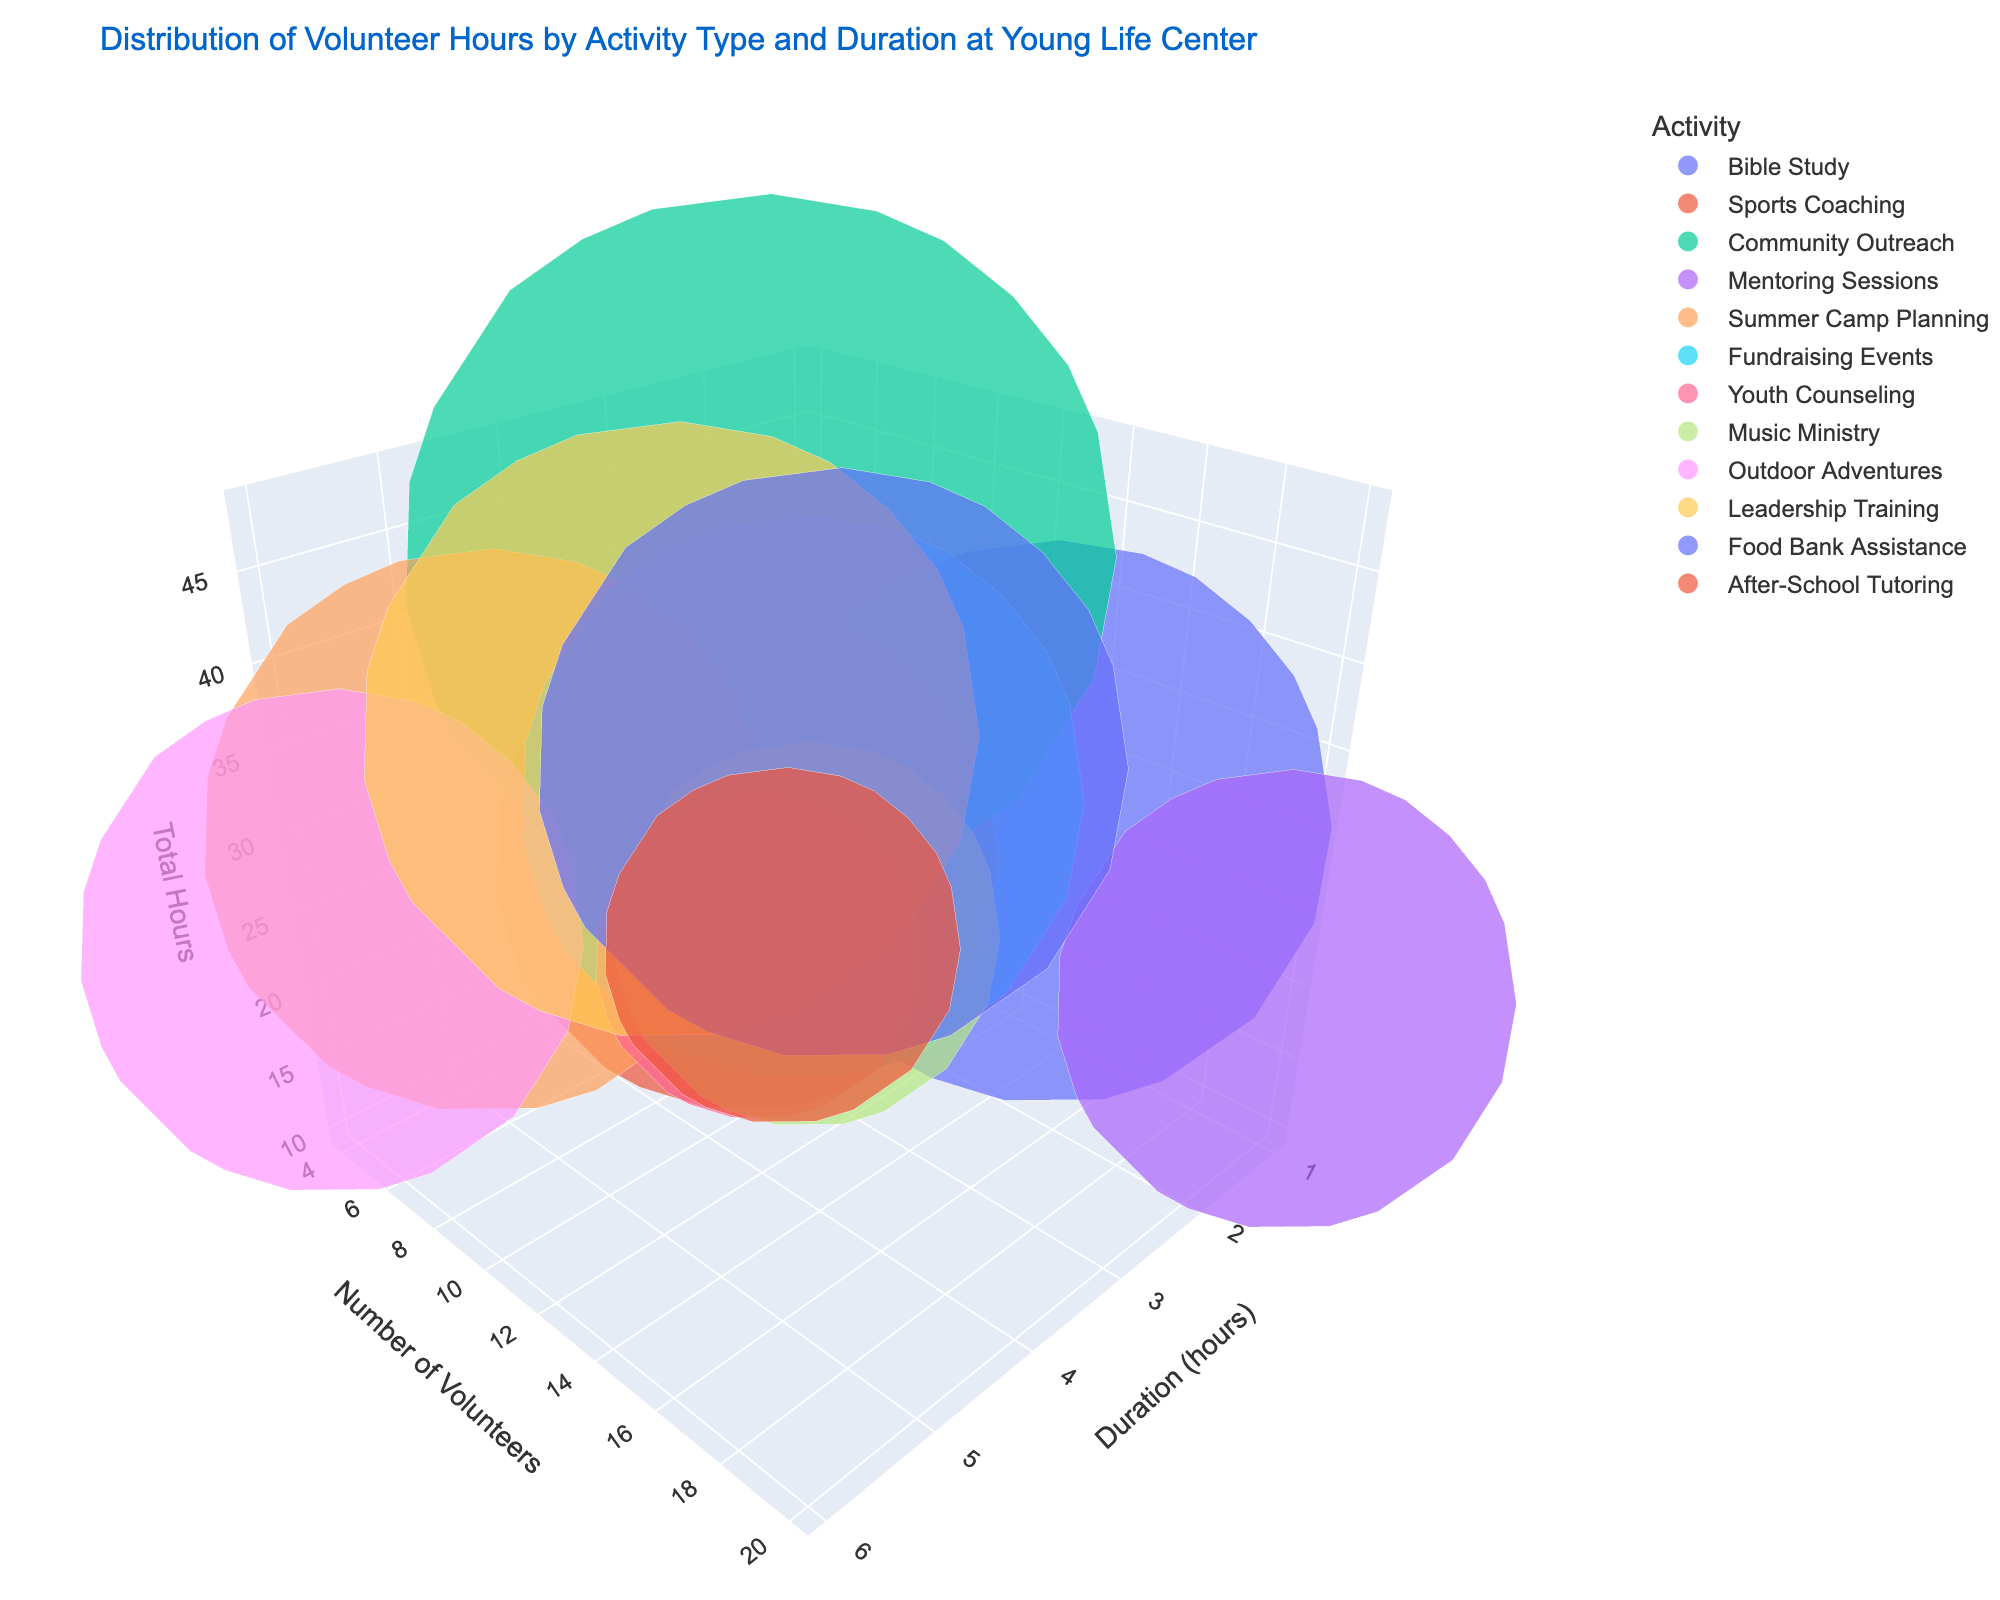What is the title of this 3D bubble chart? The title of the chart is written at the top as "Distribution of Volunteer Hours by Activity Type and Duration at Young Life Center."
Answer: Distribution of Volunteer Hours by Activity Type and Duration at Young Life Center How many activities had a total of 30 hours? Look at the data points in the chart where the 'Total Hours' axis shows 30. There are three activities with total hours of 30: Bible Study, Summer Camp Planning, and Fundraising Events.
Answer: 3 Which activity has the highest number of volunteers? Identify the data point that is placed highest on the 'Number of Volunteers' axis. The activity with the highest number of volunteers is "Mentoring Sessions" with 20 volunteers.
Answer: Mentoring Sessions What is the duration for Outdoor Adventures? Find the bubble labeled "Outdoor Adventures" and check its position along the 'Duration (hours)' axis. The duration for Outdoor Adventures is 6 hours.
Answer: 6 hours How many activities have a duration of 3 hours? Count the bubbles that align with the value 3 on the 'Duration (hours)' axis. There are three activities with a duration of 3 hours: Sports Coaching, Fundraising Events, and Food Bank Assistance.
Answer: 3 Which activity has the largest bubble size and what does it represent? Identify the bubble with the largest size, then refer to the color legend to find its activity. The largest bubble size corresponds to Community Outreach, representing total hours worked (48 hours).
Answer: Community Outreach Compare the number of volunteers for Bible Study and Youth Counseling. Which has more volunteers? Locate the bubbles for Bible Study and Youth Counseling and compare their positions on the 'Number of Volunteers' axis. Bible Study has 15 volunteers while Youth Counseling has 5, so Bible Study has more volunteers.
Answer: Bible Study Which activity has the least total hours and what is its bubble size? Find the smallest value on the 'Total Hours' axis and check the corresponding bubble. The activity is "Youth Counseling" with 10 total hours. The bubble size is derived from the formula sqrt(10) * 2, which is approximately 6.32.
Answer: Youth Counseling; 6.32 What is the relationship between duration and total hours for After-School Tutoring? Find the bubble for After-School Tutoring and note its position on both the 'Duration (hours)' and 'Total Hours' axes. After-School Tutoring has a duration of 2 hours and total hours of 12, indicating that total hours are a multiple of the duration for this activity.
Answer: Duration: 2 hours, Total Hours: 12 Which activity has the same number of volunteers as Sports Coaching but a different duration? Identify the number of volunteers for Sports Coaching (8) and find another bubble with the same number of volunteers but different duration. Community Outreach also has 8 volunteers but a different duration (4 hours).
Answer: Community Outreach 